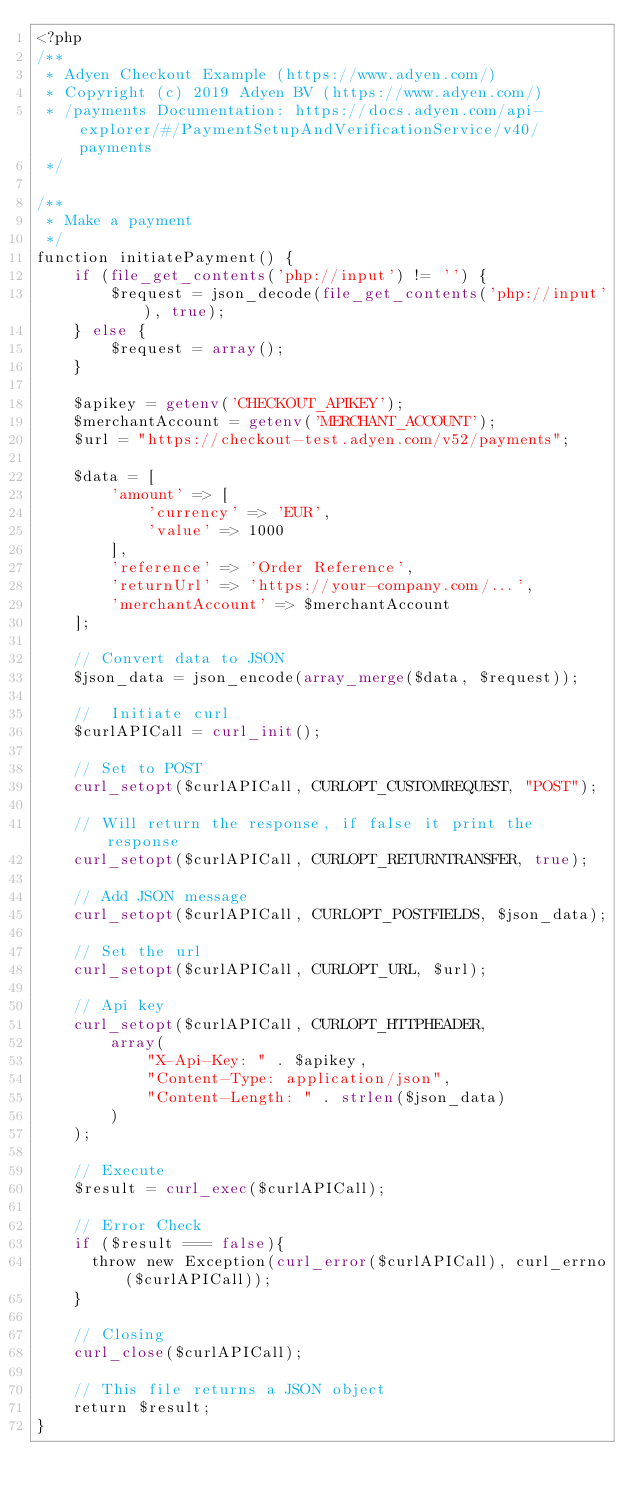Convert code to text. <code><loc_0><loc_0><loc_500><loc_500><_PHP_><?php
/**
 * Adyen Checkout Example (https://www.adyen.com/)
 * Copyright (c) 2019 Adyen BV (https://www.adyen.com/)
 * /payments Documentation: https://docs.adyen.com/api-explorer/#/PaymentSetupAndVerificationService/v40/payments
 */

/**
 * Make a payment
 */
function initiatePayment() {
    if (file_get_contents('php://input') != '') {
        $request = json_decode(file_get_contents('php://input'), true);
    } else {
        $request = array();
    }

    $apikey = getenv('CHECKOUT_APIKEY');
    $merchantAccount = getenv('MERCHANT_ACCOUNT');
    $url = "https://checkout-test.adyen.com/v52/payments";

    $data = [
        'amount' => [
            'currency' => 'EUR',
            'value' => 1000
        ],
        'reference' => 'Order Reference',
        'returnUrl' => 'https://your-company.com/...',
        'merchantAccount' => $merchantAccount
    ];

    // Convert data to JSON
    $json_data = json_encode(array_merge($data, $request));

    //  Initiate curl
    $curlAPICall = curl_init();

    // Set to POST
    curl_setopt($curlAPICall, CURLOPT_CUSTOMREQUEST, "POST");

    // Will return the response, if false it print the response
    curl_setopt($curlAPICall, CURLOPT_RETURNTRANSFER, true);

    // Add JSON message
    curl_setopt($curlAPICall, CURLOPT_POSTFIELDS, $json_data);

    // Set the url
    curl_setopt($curlAPICall, CURLOPT_URL, $url);

    // Api key
    curl_setopt($curlAPICall, CURLOPT_HTTPHEADER,
        array(
            "X-Api-Key: " . $apikey,
            "Content-Type: application/json",
            "Content-Length: " . strlen($json_data)
        )
    );

    // Execute
    $result = curl_exec($curlAPICall);

    // Error Check
    if ($result === false){
      throw new Exception(curl_error($curlAPICall), curl_errno($curlAPICall));
    }

    // Closing
    curl_close($curlAPICall);

    // This file returns a JSON object
    return $result;
}
</code> 